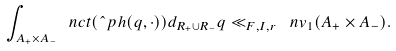<formula> <loc_0><loc_0><loc_500><loc_500>\int _ { A _ { + } \times A _ { - } } \ n c t ( \hat { \ } p h ( q , \cdot ) ) d _ { R _ { + } \cup R _ { - } } q \ll _ { F , I , r } \ n v _ { 1 } ( A _ { + } \times A _ { - } ) .</formula> 